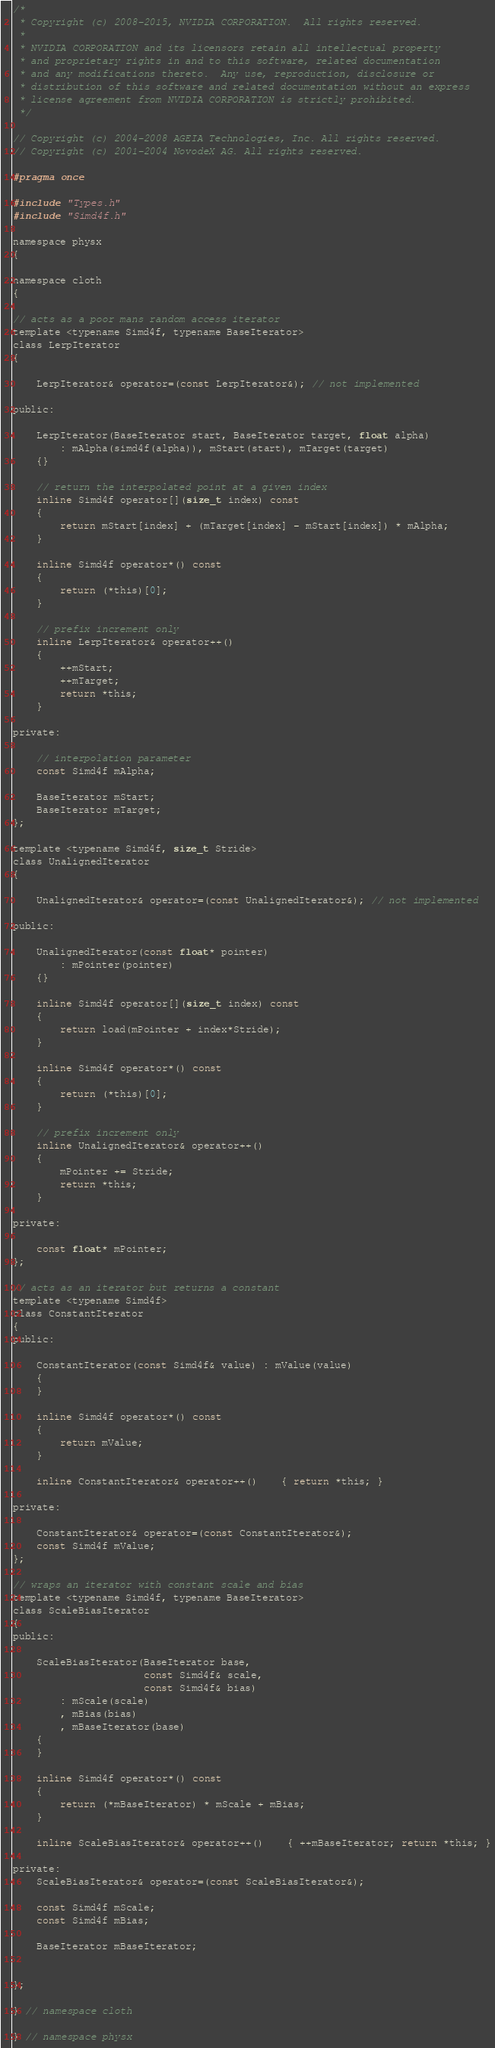<code> <loc_0><loc_0><loc_500><loc_500><_C_>/*
 * Copyright (c) 2008-2015, NVIDIA CORPORATION.  All rights reserved.
 *
 * NVIDIA CORPORATION and its licensors retain all intellectual property
 * and proprietary rights in and to this software, related documentation
 * and any modifications thereto.  Any use, reproduction, disclosure or
 * distribution of this software and related documentation without an express
 * license agreement from NVIDIA CORPORATION is strictly prohibited.
 */

// Copyright (c) 2004-2008 AGEIA Technologies, Inc. All rights reserved.
// Copyright (c) 2001-2004 NovodeX AG. All rights reserved.  

#pragma once

#include "Types.h"
#include "Simd4f.h"

namespace physx
{

namespace cloth
{

// acts as a poor mans random access iterator
template <typename Simd4f, typename BaseIterator>
class LerpIterator
{
	
	LerpIterator& operator=(const LerpIterator&); // not implemented

public:

	LerpIterator(BaseIterator start, BaseIterator target, float alpha)
		: mAlpha(simd4f(alpha)), mStart(start), mTarget(target)
	{}

	// return the interpolated point at a given index
	inline Simd4f operator[](size_t index) const
	{
		return mStart[index] + (mTarget[index] - mStart[index]) * mAlpha;
	}
	
	inline Simd4f operator*() const
	{
		return (*this)[0];
	}

	// prefix increment only
	inline LerpIterator& operator++()
	{
		++mStart;
		++mTarget;
		return *this;
	}

private:

	// interpolation parameter
	const Simd4f mAlpha;

	BaseIterator mStart;
	BaseIterator mTarget;
};

template <typename Simd4f, size_t Stride>
class UnalignedIterator
{

	UnalignedIterator& operator=(const UnalignedIterator&); // not implemented

public:

	UnalignedIterator(const float* pointer)
		: mPointer(pointer)
	{}

	inline Simd4f operator[](size_t index) const
	{
		return load(mPointer + index*Stride);
	}

	inline Simd4f operator*() const
	{
		return (*this)[0];
	}

	// prefix increment only
	inline UnalignedIterator& operator++()
	{
		mPointer += Stride;
		return *this;
	}

private:

	const float* mPointer;
};

// acts as an iterator but returns a constant
template <typename Simd4f>
class ConstantIterator
{
public:

	ConstantIterator(const Simd4f& value) : mValue(value) 
	{
	}

	inline Simd4f operator*() const
	{
		return mValue;
	}

	inline ConstantIterator& operator++()	{ return *this; }

private:

	ConstantIterator& operator=(const ConstantIterator&);
	const Simd4f mValue;
};

// wraps an iterator with constant scale and bias
template <typename Simd4f, typename BaseIterator>
class ScaleBiasIterator
{
public:

	ScaleBiasIterator(BaseIterator base, 
					  const Simd4f& scale,
					  const Simd4f& bias) 
		: mScale(scale) 
		, mBias(bias)
        , mBaseIterator(base)
	{
	}

	inline Simd4f operator*() const
	{
		return (*mBaseIterator) * mScale + mBias;
	}

	inline ScaleBiasIterator& operator++()	{ ++mBaseIterator; return *this; }

private:
	ScaleBiasIterator& operator=(const ScaleBiasIterator&);

	const Simd4f mScale;
	const Simd4f mBias;

	BaseIterator mBaseIterator;
	

};

} // namespace cloth

} // namespace physx
</code> 